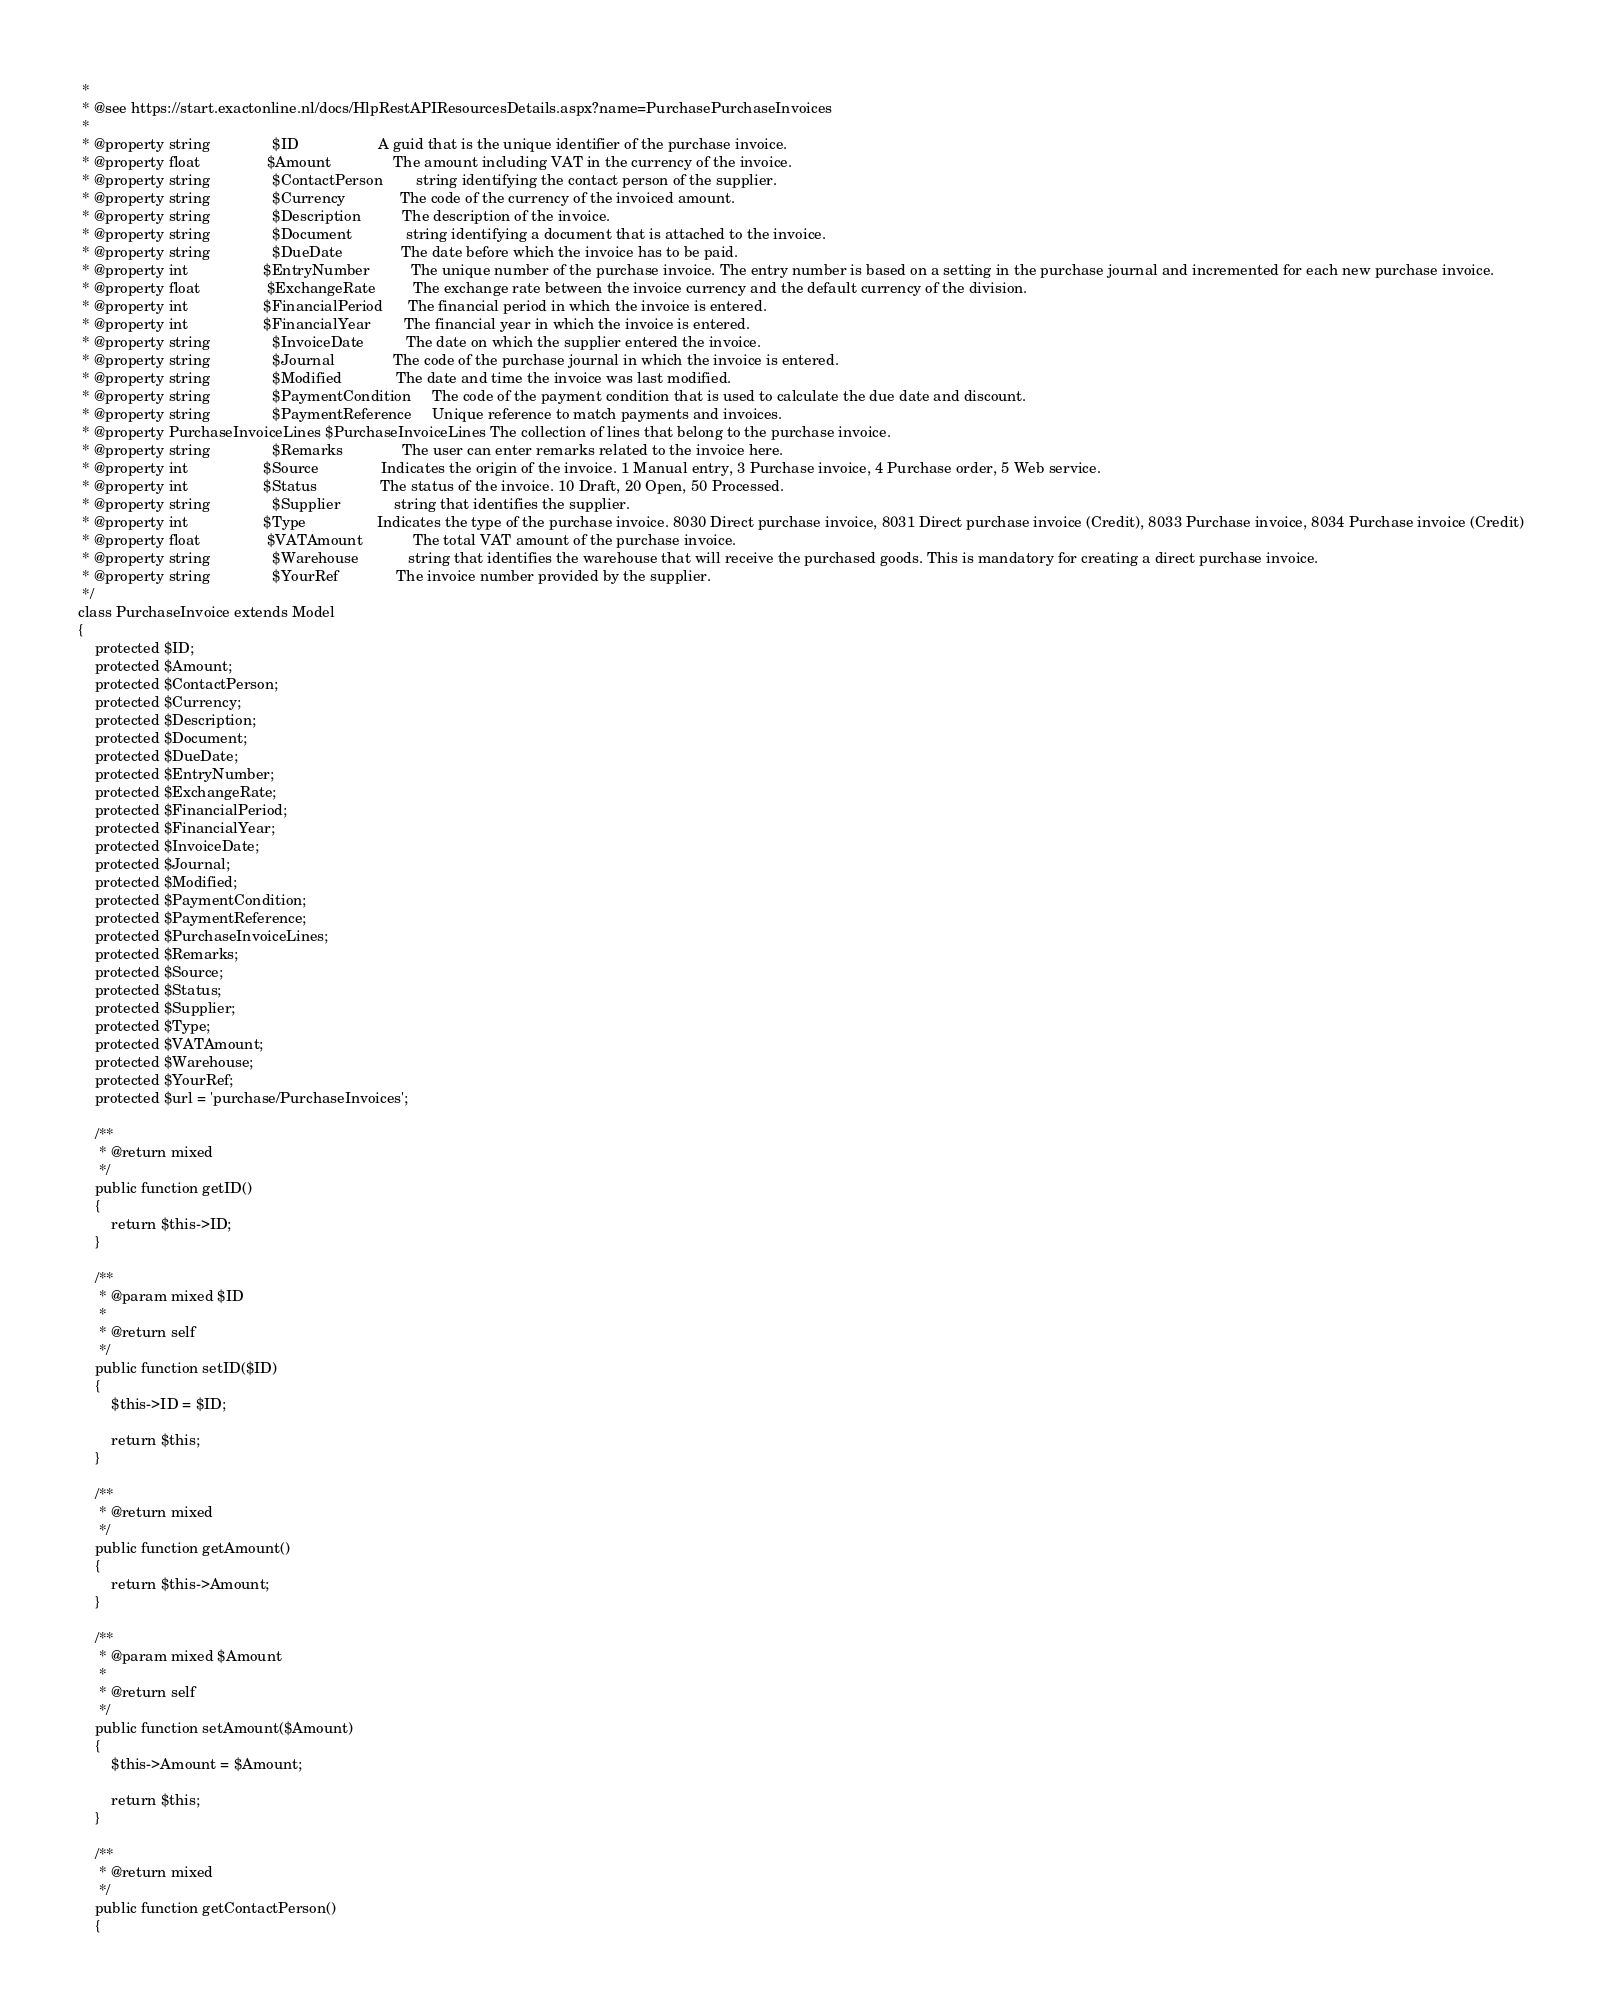Convert code to text. <code><loc_0><loc_0><loc_500><loc_500><_PHP_> *
 * @see https://start.exactonline.nl/docs/HlpRestAPIResourcesDetails.aspx?name=PurchasePurchaseInvoices
 *
 * @property string               $ID                   A guid that is the unique identifier of the purchase invoice.
 * @property float                $Amount               The amount including VAT in the currency of the invoice.
 * @property string               $ContactPerson        string identifying the contact person of the supplier.
 * @property string               $Currency             The code of the currency of the invoiced amount.
 * @property string               $Description          The description of the invoice.
 * @property string               $Document             string identifying a document that is attached to the invoice.
 * @property string               $DueDate              The date before which the invoice has to be paid.
 * @property int                  $EntryNumber          The unique number of the purchase invoice. The entry number is based on a setting in the purchase journal and incremented for each new purchase invoice.
 * @property float                $ExchangeRate         The exchange rate between the invoice currency and the default currency of the division.
 * @property int                  $FinancialPeriod      The financial period in which the invoice is entered.
 * @property int                  $FinancialYear        The financial year in which the invoice is entered.
 * @property string               $InvoiceDate          The date on which the supplier entered the invoice.
 * @property string               $Journal              The code of the purchase journal in which the invoice is entered.
 * @property string               $Modified             The date and time the invoice was last modified.
 * @property string               $PaymentCondition     The code of the payment condition that is used to calculate the due date and discount.
 * @property string               $PaymentReference     Unique reference to match payments and invoices.
 * @property PurchaseInvoiceLines $PurchaseInvoiceLines The collection of lines that belong to the purchase invoice.
 * @property string               $Remarks              The user can enter remarks related to the invoice here.
 * @property int                  $Source               Indicates the origin of the invoice. 1 Manual entry, 3 Purchase invoice, 4 Purchase order, 5 Web service.
 * @property int                  $Status               The status of the invoice. 10 Draft, 20 Open, 50 Processed.
 * @property string               $Supplier             string that identifies the supplier.
 * @property int                  $Type                 Indicates the type of the purchase invoice. 8030 Direct purchase invoice, 8031 Direct purchase invoice (Credit), 8033 Purchase invoice, 8034 Purchase invoice (Credit)
 * @property float                $VATAmount            The total VAT amount of the purchase invoice.
 * @property string               $Warehouse            string that identifies the warehouse that will receive the purchased goods. This is mandatory for creating a direct purchase invoice.
 * @property string               $YourRef              The invoice number provided by the supplier.
 */
class PurchaseInvoice extends Model
{
    protected $ID;
    protected $Amount;
    protected $ContactPerson;
    protected $Currency;
    protected $Description;
    protected $Document;
    protected $DueDate;
    protected $EntryNumber;
    protected $ExchangeRate;
    protected $FinancialPeriod;
    protected $FinancialYear;
    protected $InvoiceDate;
    protected $Journal;
    protected $Modified;
    protected $PaymentCondition;
    protected $PaymentReference;
    protected $PurchaseInvoiceLines;
    protected $Remarks;
    protected $Source;
    protected $Status;
    protected $Supplier;
    protected $Type;
    protected $VATAmount;
    protected $Warehouse;
    protected $YourRef;
    protected $url = 'purchase/PurchaseInvoices';

    /**
     * @return mixed
     */
    public function getID()
    {
        return $this->ID;
    }

    /**
     * @param mixed $ID
     *
     * @return self
     */
    public function setID($ID)
    {
        $this->ID = $ID;

        return $this;
    }

    /**
     * @return mixed
     */
    public function getAmount()
    {
        return $this->Amount;
    }

    /**
     * @param mixed $Amount
     *
     * @return self
     */
    public function setAmount($Amount)
    {
        $this->Amount = $Amount;

        return $this;
    }

    /**
     * @return mixed
     */
    public function getContactPerson()
    {</code> 